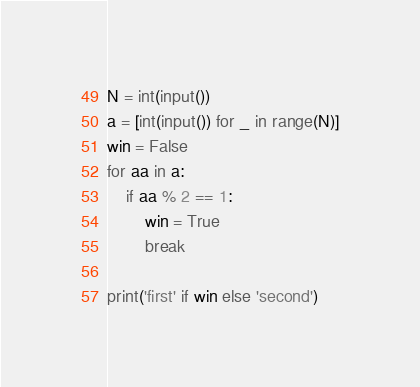Convert code to text. <code><loc_0><loc_0><loc_500><loc_500><_Python_>N = int(input())
a = [int(input()) for _ in range(N)]
win = False
for aa in a:
    if aa % 2 == 1:
        win = True
        break

print('first' if win else 'second')
</code> 